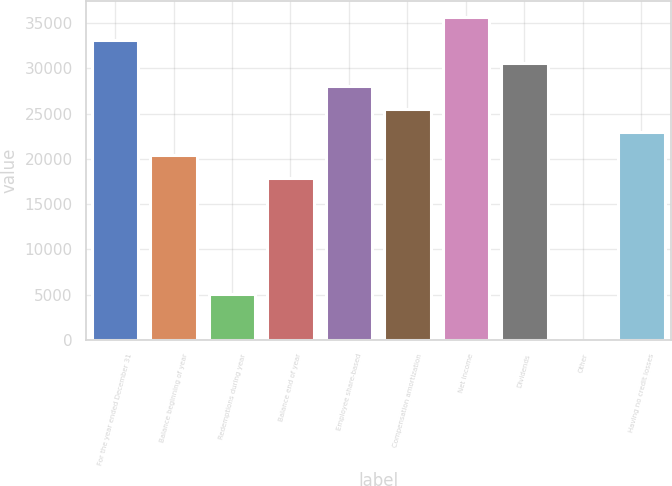Convert chart. <chart><loc_0><loc_0><loc_500><loc_500><bar_chart><fcel>For the year ended December 31<fcel>Balance beginning of year<fcel>Redemptions during year<fcel>Balance end of year<fcel>Employee share-based<fcel>Compensation amortization<fcel>Net income<fcel>Dividends<fcel>Other<fcel>Having no credit losses<nl><fcel>33115.4<fcel>20381.4<fcel>5100.6<fcel>17834.6<fcel>28021.8<fcel>25475<fcel>35662.2<fcel>30568.6<fcel>7<fcel>22928.2<nl></chart> 